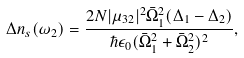<formula> <loc_0><loc_0><loc_500><loc_500>\Delta n _ { s } ( \omega _ { 2 } ) = \frac { 2 N | \mu _ { 3 2 } | ^ { 2 } \bar { \Omega } ^ { 2 } _ { 1 } ( \Delta _ { 1 } - \Delta _ { 2 } ) } { \hbar { \epsilon } _ { 0 } ( \bar { \Omega } ^ { 2 } _ { 1 } + \bar { \Omega } ^ { 2 } _ { 2 } ) ^ { 2 } } ,</formula> 